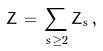Convert formula to latex. <formula><loc_0><loc_0><loc_500><loc_500>Z \, = \, \sum _ { s \geq 2 } Z _ { s } \, ,</formula> 